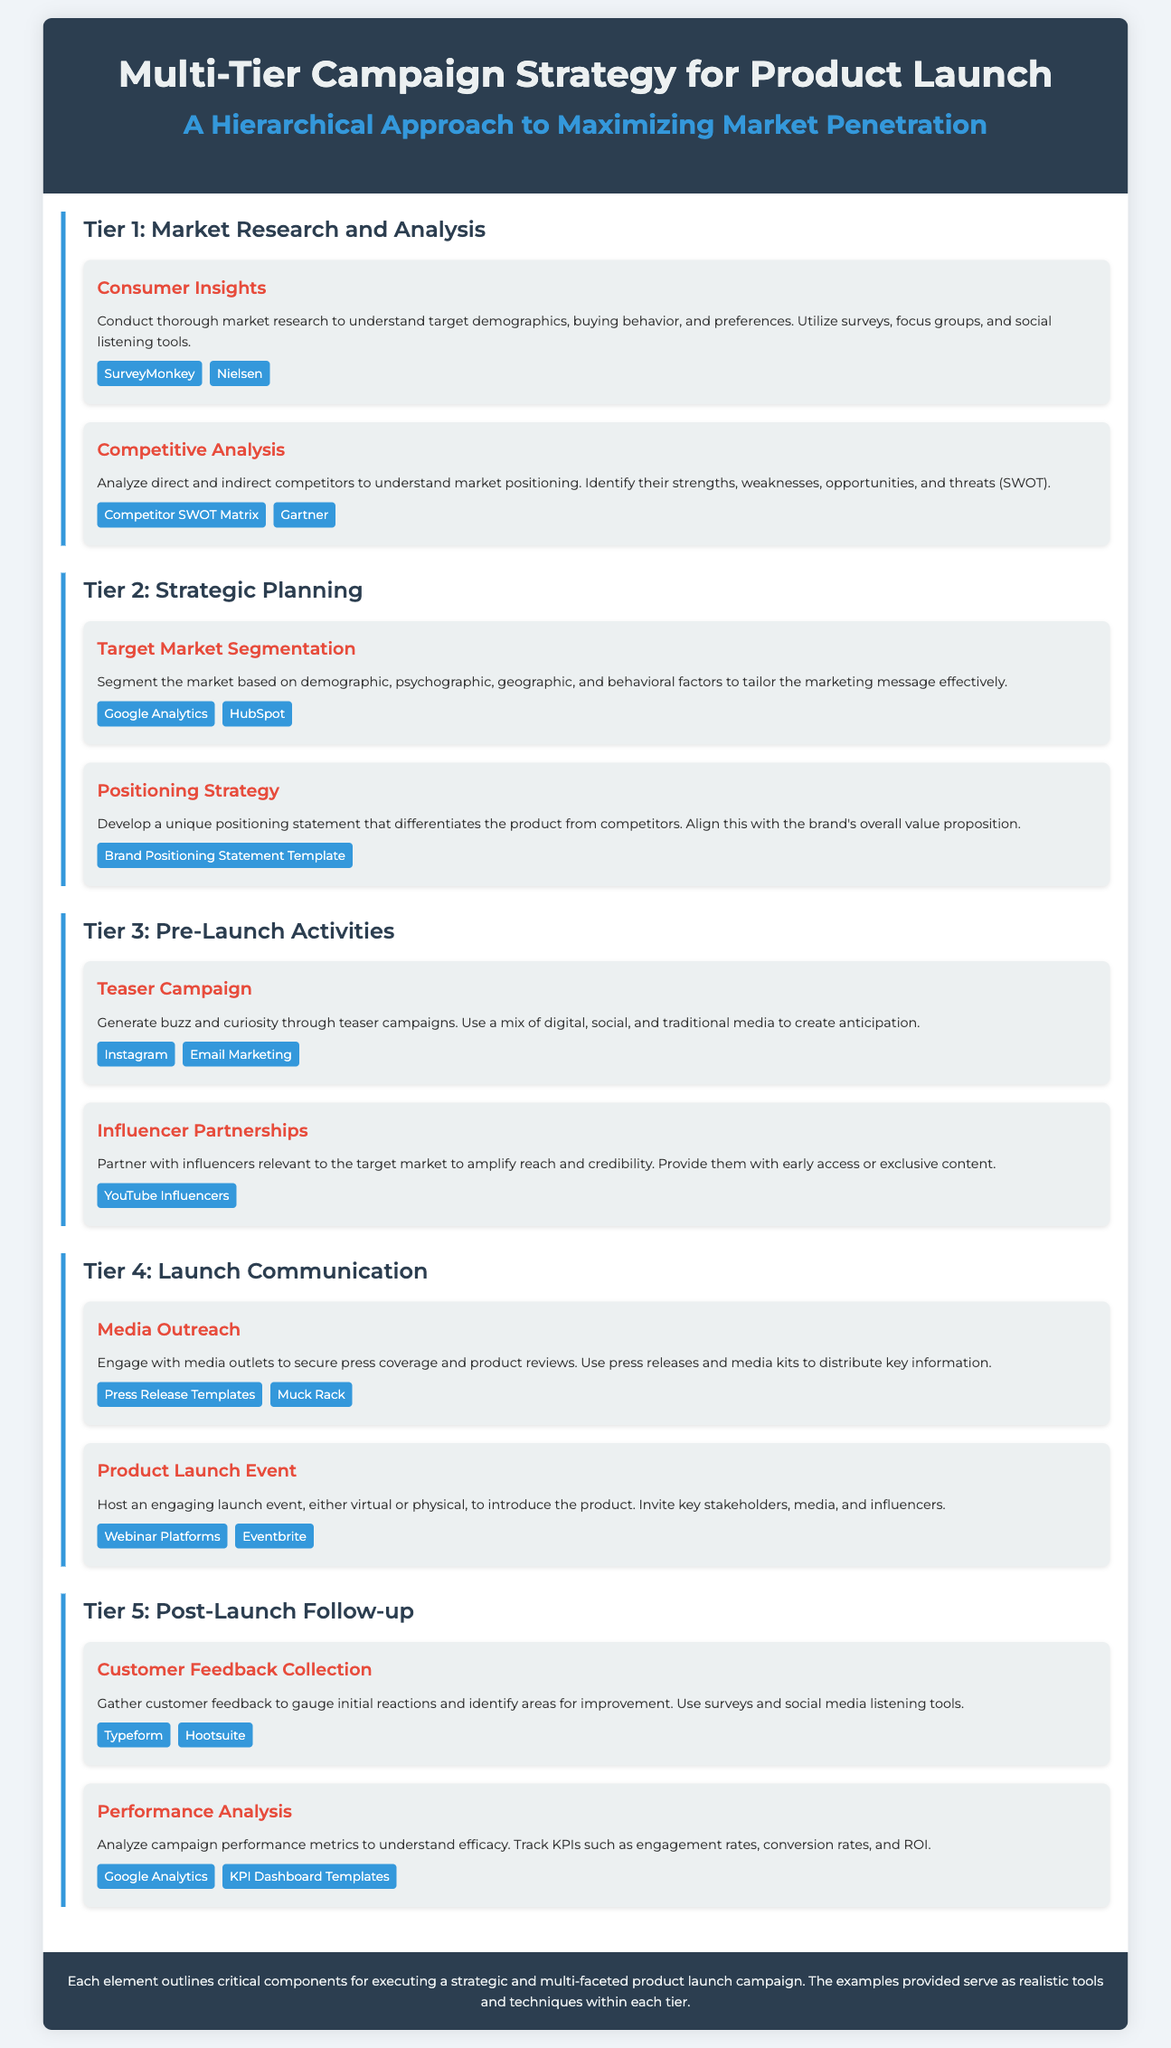What is the title of the infographic? The title is presented prominently at the top of the document, indicating the subject matter covered.
Answer: Multi-Tier Campaign Strategy for Product Launch How many tiers are in the campaign strategy? The document lists five distinct tiers for the campaign strategy, each focusing on different aspects of the launch process.
Answer: 5 What is the focus of Tier 1? The first tier highlights the importance of understanding the market and consumers before strategizing, as indicated by the associated elements.
Answer: Market Research and Analysis Which tool is mentioned for Competitive Analysis? The document provides examples of tools that can be utilized for specific tasks, showing one example relevant to competitive analysis.
Answer: Gartner What is included in the Pre-Launch Activities tier? This tier consists of two key elements that are strategies designed to create anticipation and visibility before the product launch.
Answer: Teaser Campaign, Influencer Partnerships Which element emphasizes customer feedback? One of the critical elements in the post-launch process highlights the necessity to gather consumer opinions on the product after launch.
Answer: Customer Feedback Collection What does the Positioning Strategy develop? The Positioning Strategy aims to create a specific marketing framework to effectively distinguish the product within the competitive landscape.
Answer: Unique positioning statement Name one example of a tool used for Performance Analysis. The document lists examples of tools that could be used to assess the success of the campaign metrics specified in the performance analysis process.
Answer: Google Analytics What should be included for Media Outreach? This element outlines the actions and materials recommended to engage media professionals and acquire coverage for the product launch.
Answer: Press releases and media kits 